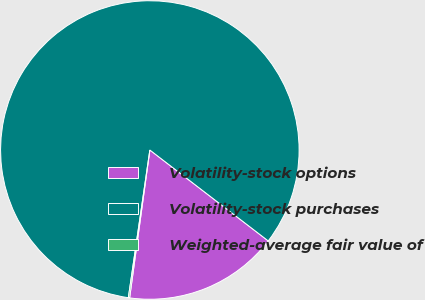<chart> <loc_0><loc_0><loc_500><loc_500><pie_chart><fcel>Volatility-stock options<fcel>Volatility-stock purchases<fcel>Weighted-average fair value of<nl><fcel>16.74%<fcel>83.12%<fcel>0.14%<nl></chart> 